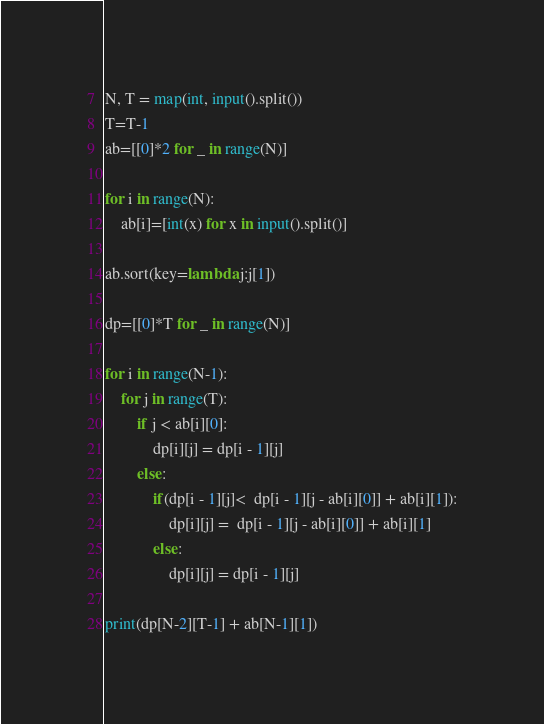Convert code to text. <code><loc_0><loc_0><loc_500><loc_500><_Python_>N, T = map(int, input().split())
T=T-1
ab=[[0]*2 for _ in range(N)]

for i in range(N):
    ab[i]=[int(x) for x in input().split()]

ab.sort(key=lambda j:j[1])

dp=[[0]*T for _ in range(N)]

for i in range(N-1):
    for j in range(T):
        if j < ab[i][0]:
            dp[i][j] = dp[i - 1][j]
        else:
            if(dp[i - 1][j]<  dp[i - 1][j - ab[i][0]] + ab[i][1]):
                dp[i][j] =  dp[i - 1][j - ab[i][0]] + ab[i][1]
            else:
                dp[i][j] = dp[i - 1][j]

print(dp[N-2][T-1] + ab[N-1][1])</code> 